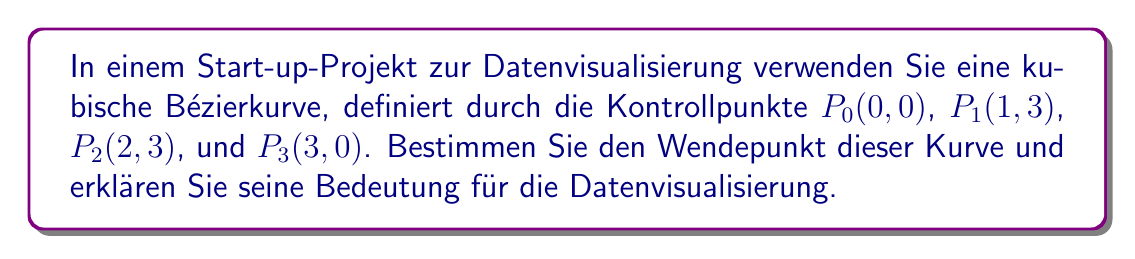Can you solve this math problem? 1) Die parametrische Darstellung einer kubischen Bézierkurve ist:

   $$B(t) = (1-t)^3P_0 + 3t(1-t)^2P_1 + 3t^2(1-t)P_2 + t^3P_3, \quad 0 \leq t \leq 1$$

2) Der Wendepunkt tritt auf, wenn die zweite Ableitung $B''(t)$ gleich Null ist.

3) Berechnen wir $B''(t)$:
   
   $$B''(t) = 6(1-t)(P_0 - 2P_1 + P_2) + 6t(P_1 - 2P_2 + P_3)$$

4) Setzen wir $B''(t) = 0$ und lösen nach $t$:

   $$6(1-t)(P_0 - 2P_1 + P_2) = -6t(P_1 - 2P_2 + P_3)$$
   $$(1-t)((0,0) - 2(1,3) + (2,3)) = -t((1,3) - 2(2,3) + (3,0))$$
   $$(1-t)(0,-3) = -t(-1,-3)$$

5) Lösen wir diese Gleichung:

   $$t = \frac{1}{2}$$

6) Der Wendepunkt liegt also bei $t = \frac{1}{2}$. Einsetzen in die ursprüngliche Gleichung:

   $$B(\frac{1}{2}) = \frac{1}{8}(P_0 + 3P_1 + 3P_2 + P_3) = (\frac{3}{2}, \frac{9}{4})$$

7) Bedeutung für die Datenvisualisierung:
   - Der Wendepunkt markiert, wo die Kurve ihre Krümmungsrichtung ändert.
   - In der Datenvisualisierung kann dies auf einen Trendwechsel oder einen kritischen Punkt in den Daten hinweisen.
   - Die Position bei $t = \frac{1}{2}$ zeigt, dass dieser Punkt genau in der Mitte der Parametrisierung liegt, was eine ausgewogene Darstellung der Datentrends vor und nach diesem Punkt ermöglicht.
Answer: Wendepunkt bei $(\frac{3}{2}, \frac{9}{4})$; markiert Trendwechsel in Daten. 